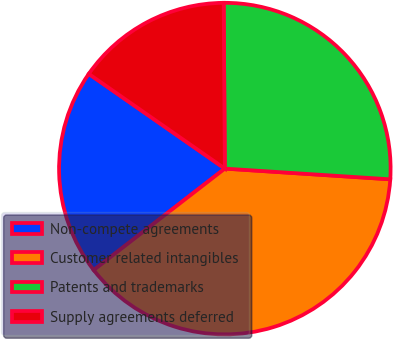Convert chart. <chart><loc_0><loc_0><loc_500><loc_500><pie_chart><fcel>Non-compete agreements<fcel>Customer related intangibles<fcel>Patents and trademarks<fcel>Supply agreements deferred<nl><fcel>20.16%<fcel>38.49%<fcel>26.14%<fcel>15.21%<nl></chart> 